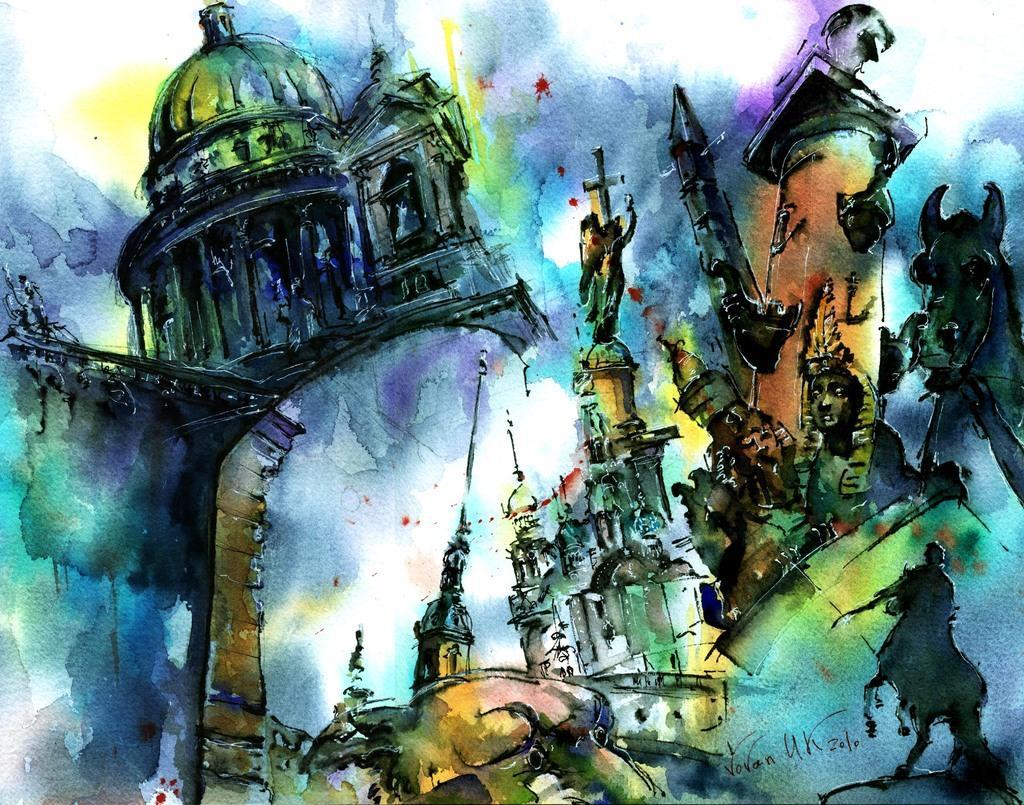Can you describe this image briefly? This might be a painting in this image there is a building, cross, animals and some other objects. 